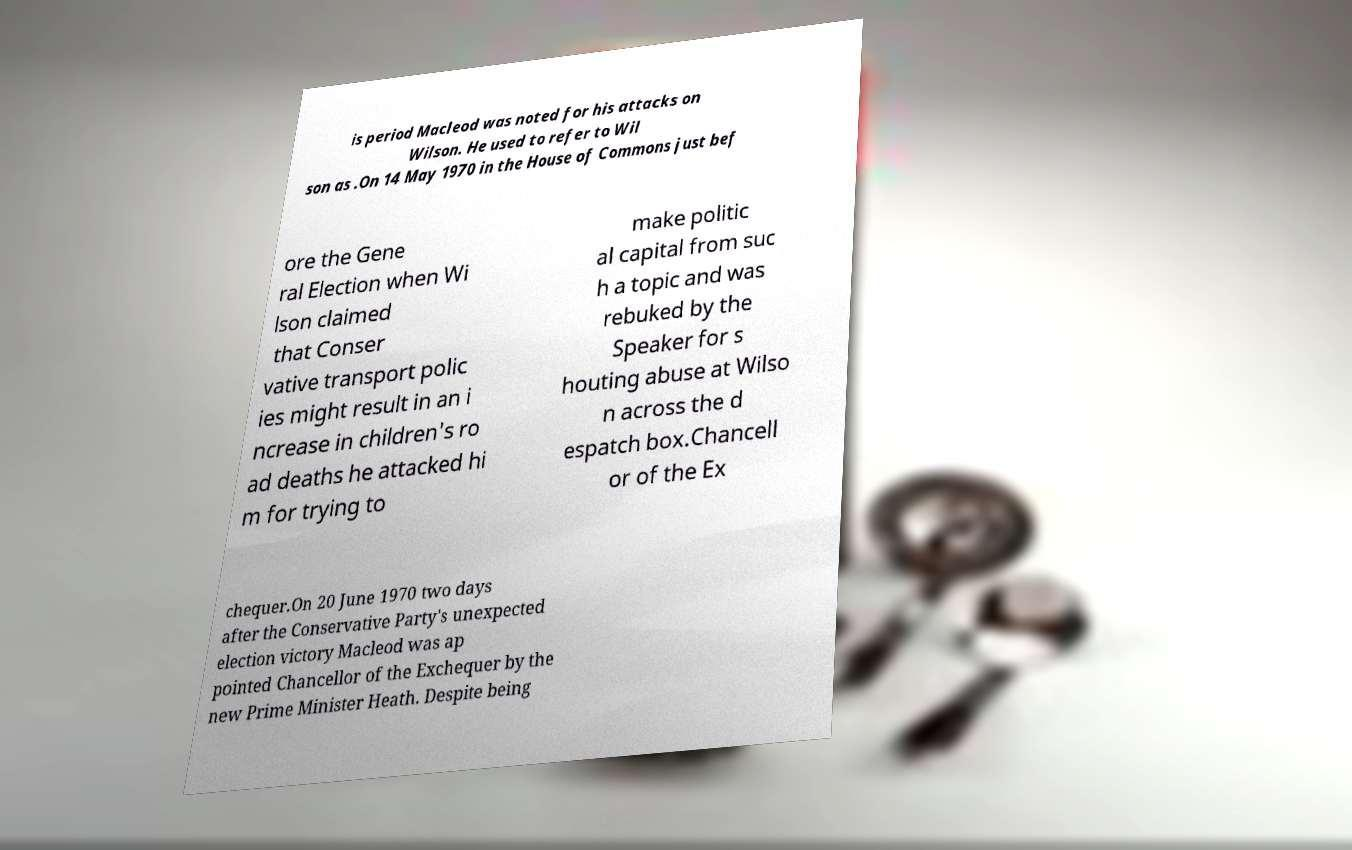Can you read and provide the text displayed in the image?This photo seems to have some interesting text. Can you extract and type it out for me? is period Macleod was noted for his attacks on Wilson. He used to refer to Wil son as .On 14 May 1970 in the House of Commons just bef ore the Gene ral Election when Wi lson claimed that Conser vative transport polic ies might result in an i ncrease in children's ro ad deaths he attacked hi m for trying to make politic al capital from suc h a topic and was rebuked by the Speaker for s houting abuse at Wilso n across the d espatch box.Chancell or of the Ex chequer.On 20 June 1970 two days after the Conservative Party's unexpected election victory Macleod was ap pointed Chancellor of the Exchequer by the new Prime Minister Heath. Despite being 